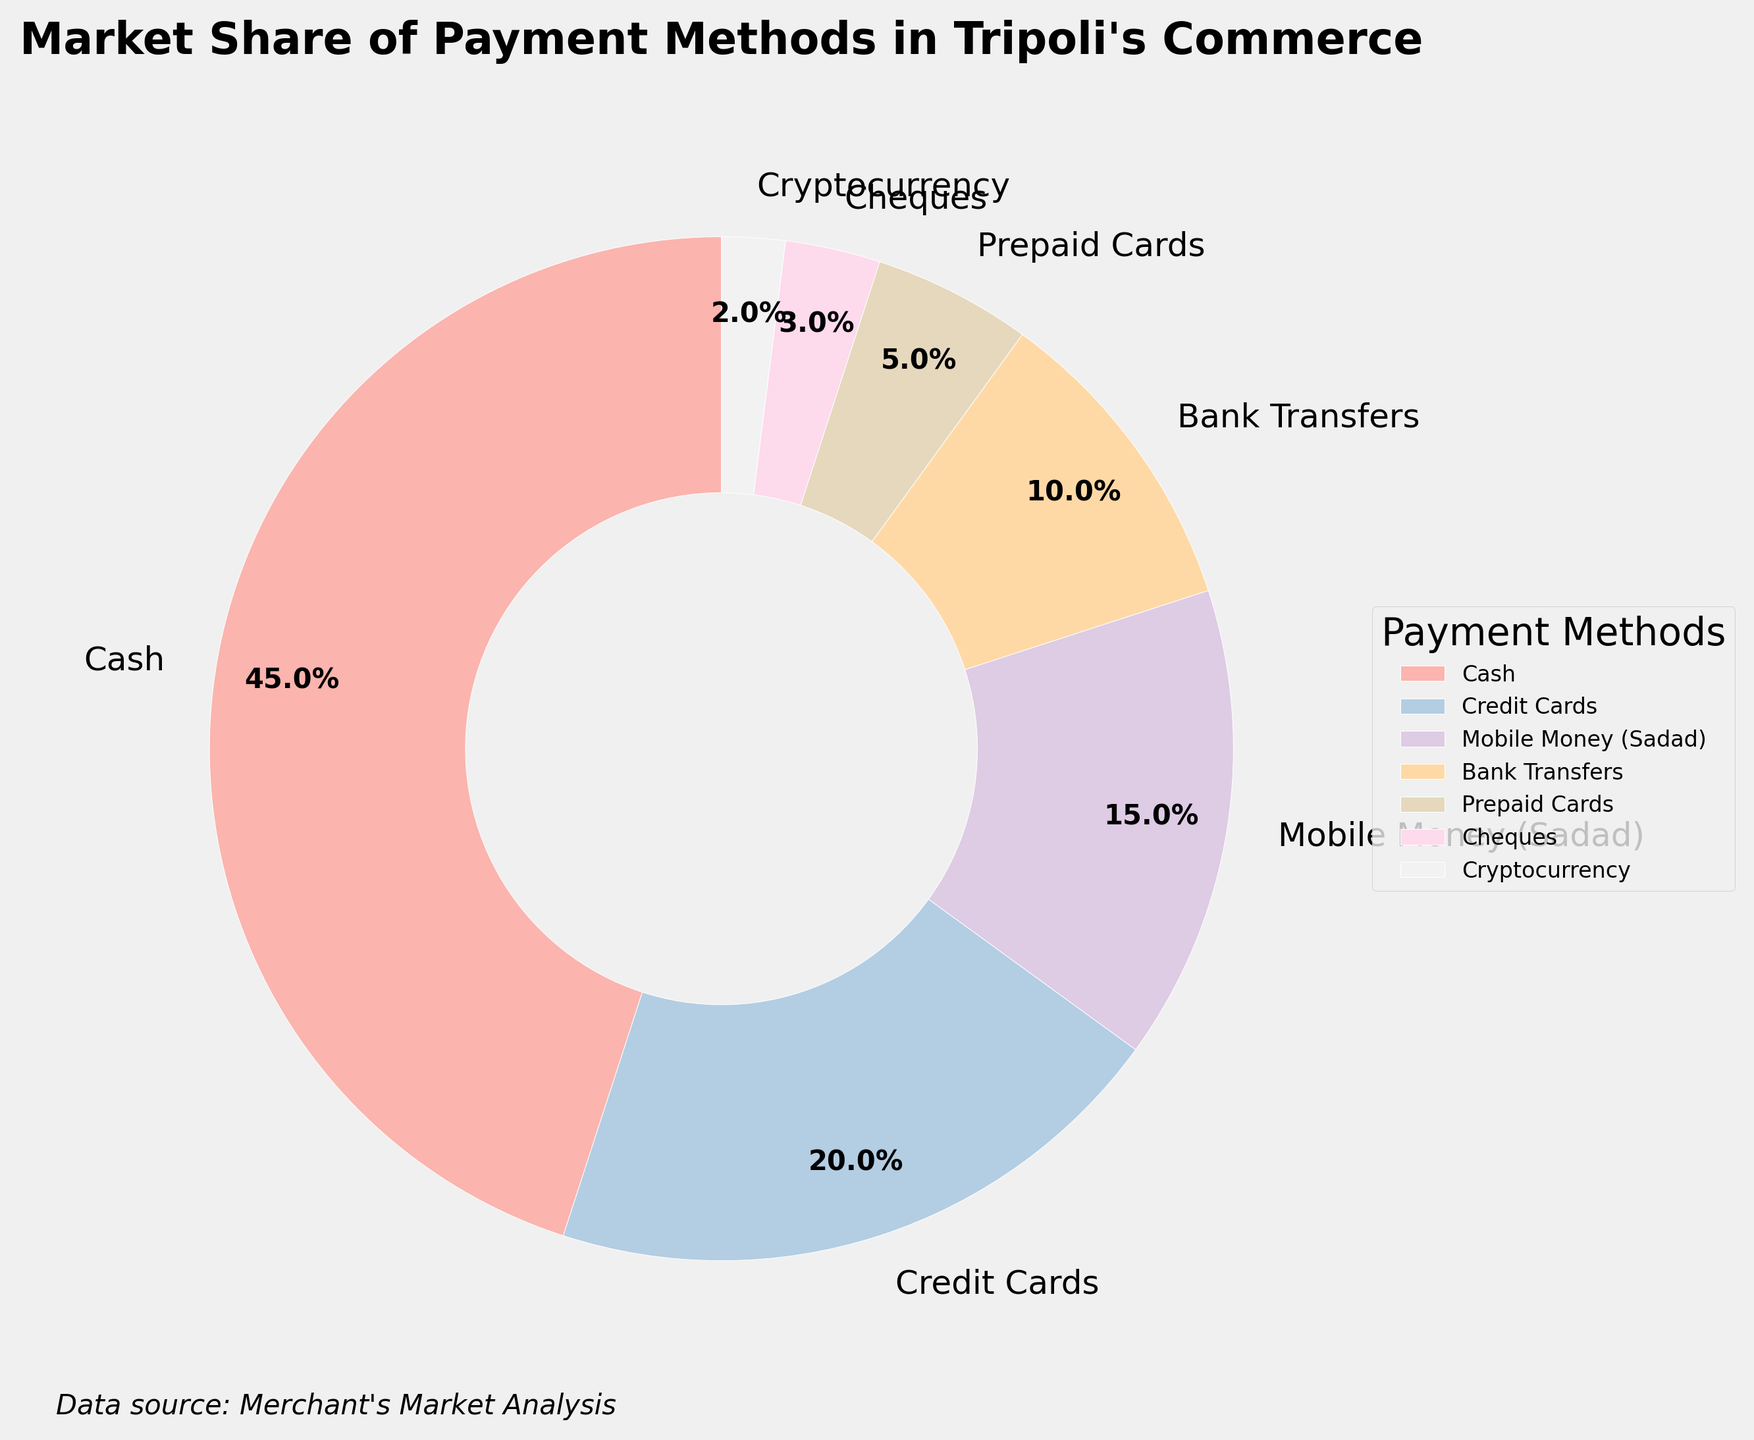What is the market share of the most popular payment method? The most popular payment method, represented by the largest wedge in the pie chart, is Cash. Its market share is indicated inside the wedge, which is 45%.
Answer: 45% What is the total market share of electronic payment methods (Credit Cards, Mobile Money, Bank Transfers, and Cryptocurrency)? Look at the market shares for each electronic payment method: Credit Cards (20%), Mobile Money (15%), Bank Transfers (10%), and Cryptocurrency (2%). Adding these together gives 20 + 15 + 10 + 2 = 47%.
Answer: 47% Which payment method has the smallest market share, and what is its percentage? The smallest wedge corresponds to Cryptocurrency. The percentage inside this wedge is 2%.
Answer: Cryptocurrency, 2% How many percentage points more market share does Cash have compared to Credit Cards? Cash has a market share of 45%, and Credit Cards have a market share of 20%. The difference is 45 - 20 = 25 percentage points.
Answer: 25 percentage points Which payment methods occupy half of the total market share together? The total market share is 100%. Half of this is 50%. Cash (45%) and Credit Cards (20%) together make up 45 + 20 = 65%. This exceeds half, so check smaller groups: Cash (45%) plus the next method, Mobile Money (15%), sums to 45 + 15 = 60%. Still too high, so only Cash and one other method don't exceed 50%. Cash alone is 45%. Thus, Cash (45%) plus Prepaid Cards (5%) exactly hits 50%.
Answer: Cash and Prepaid Cards What is the combined market share of the less popular payment methods (Prepaid Cards, Cheques, and Cryptocurrency)? The market shares for these methods are: Prepaid Cards (5%), Cheques (3%), and Cryptocurrency (2%). Adding these together gives 5 + 3 + 2 = 10%.
Answer: 10% Is the market share of Cheques greater or lesser than Bank Transfers? The percentage for Cheques is 3%, and for Bank Transfers, it is 10%. Since 3 is less than 10, Cheques have a lesser market share than Bank Transfers.
Answer: Lesser What color represents Mobile Money (Sadad) in the pie chart? The pie wedges are colored in a gradient of pastel shades. Observing the labels and their corresponding wedges, the color of the Mobile Money wedge is a medium pink pastel color.
Answer: Medium pink pastel What is the average market share of all the payment methods listed? To find the average market share, add up all individual shares: 45 + 20 + 15 + 10 + 5 + 3 + 2 = 100. Then divide by the number of methods (7): 100 / 7 ≈ 14.29%.
Answer: Approximately 14.29% Which is larger: the market share of Mobile Money or the combined market share of Prepaid Cards and Cheques? The market share of Mobile Money is 15%. The combined market share of Prepaid Cards and Cheques is 5 + 3 = 8%. Since 15 is greater than 8, Mobile Money has a larger market share.
Answer: Mobile Money 